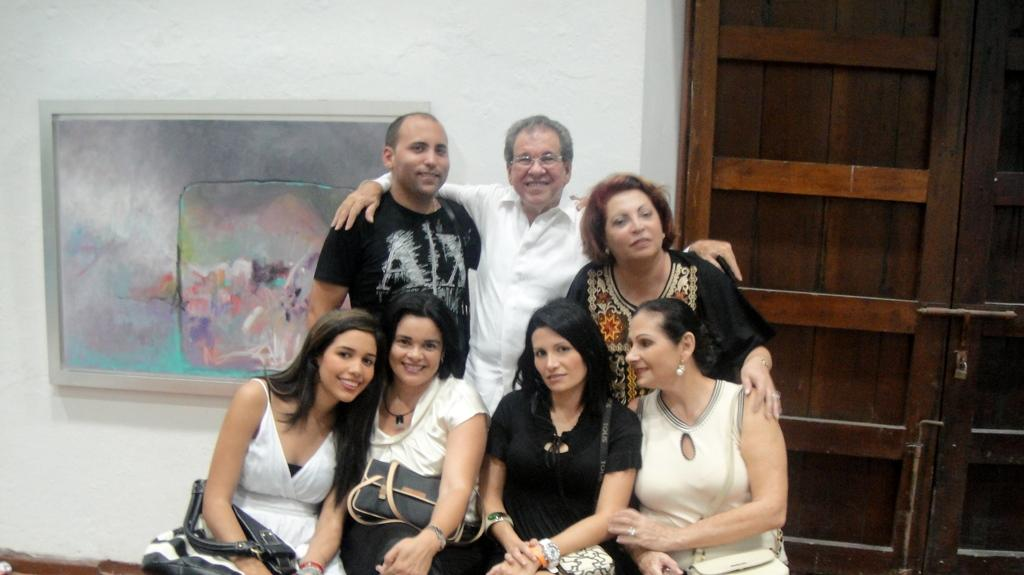How many people are in the image? There are four people in the image. What are the people doing in the image? The people are sitting. What are the people holding or carrying in the image? The people are carrying bags. What can be seen on the wall in the background of the image? There is a frame on a wall in the background. What type of door is visible in the background of the image? There is a wooden door in the background. What type of engine can be seen in the image? There is no engine present in the image. What kind of bone is visible in the image? There is no bone visible in the image. 